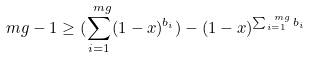Convert formula to latex. <formula><loc_0><loc_0><loc_500><loc_500>\ m g - 1 \geq ( \sum _ { i = 1 } ^ { \ m g } ( 1 - x ) ^ { b _ { i } } ) - ( 1 - x ) ^ { \sum _ { i = 1 } ^ { \ m g } b _ { i } }</formula> 